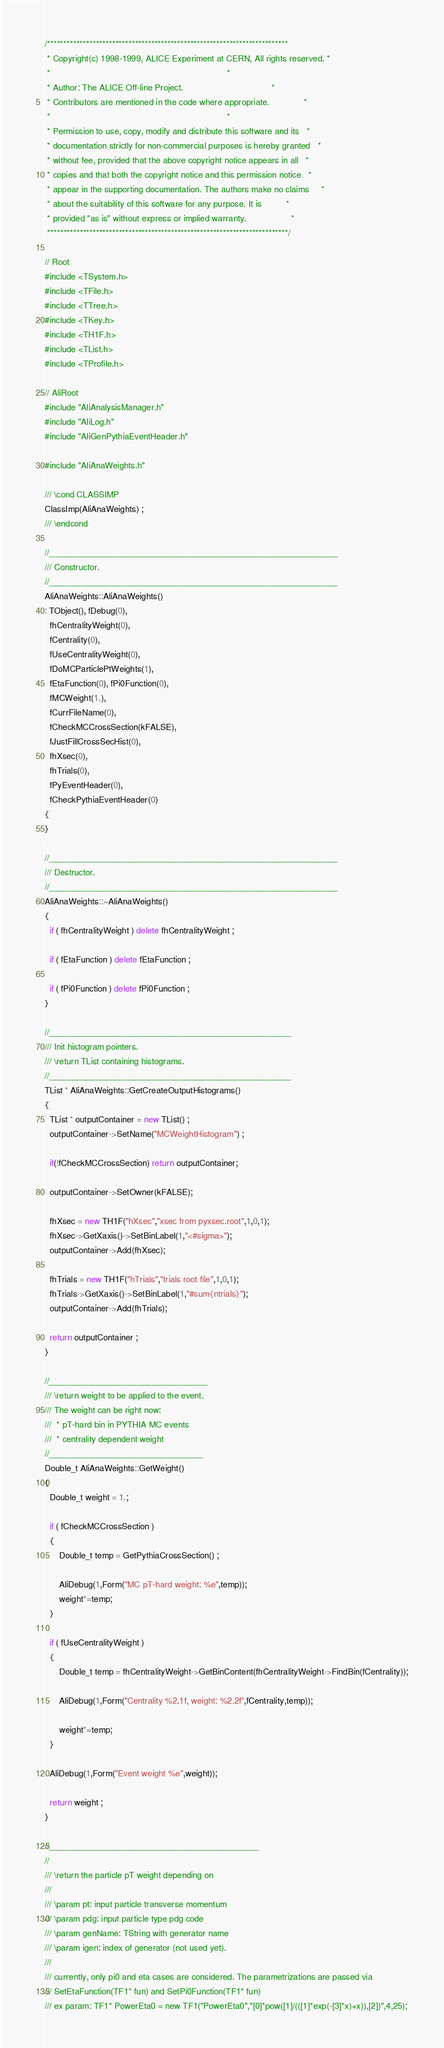Convert code to text. <code><loc_0><loc_0><loc_500><loc_500><_C++_>/**************************************************************************
 * Copyright(c) 1998-1999, ALICE Experiment at CERN, All rights reserved. *
 *                                                                        *
 * Author: The ALICE Off-line Project.                                    *
 * Contributors are mentioned in the code where appropriate.              *
 *                                                                        *
 * Permission to use, copy, modify and distribute this software and its   *
 * documentation strictly for non-commercial purposes is hereby granted   *
 * without fee, provided that the above copyright notice appears in all   *
 * copies and that both the copyright notice and this permission notice   *
 * appear in the supporting documentation. The authors make no claims     *
 * about the suitability of this software for any purpose. It is          *
 * provided "as is" without express or implied warranty.                  *
 **************************************************************************/

// Root
#include <TSystem.h>
#include <TFile.h>
#include <TTree.h>
#include <TKey.h>
#include <TH1F.h>
#include <TList.h>
#include <TProfile.h>

// AliRoot
#include "AliAnalysisManager.h"
#include "AliLog.h"
#include "AliGenPythiaEventHeader.h"

#include "AliAnaWeights.h"

/// \cond CLASSIMP
ClassImp(AliAnaWeights) ;
/// \endcond

//______________________________________________________________
/// Constructor.
//______________________________________________________________
AliAnaWeights::AliAnaWeights() 
: TObject(), fDebug(0),
  fhCentralityWeight(0),
  fCentrality(0),
  fUseCentralityWeight(0),
  fDoMCParticlePtWeights(1),
  fEtaFunction(0), fPi0Function(0), 
  fMCWeight(1.),
  fCurrFileName(0),
  fCheckMCCrossSection(kFALSE),
  fJustFillCrossSecHist(0),
  fhXsec(0),
  fhTrials(0),
  fPyEventHeader(0),
  fCheckPythiaEventHeader(0)
{
}

//______________________________________________________________
/// Destructor.
//______________________________________________________________
AliAnaWeights::~AliAnaWeights() 
{ 
  if ( fhCentralityWeight ) delete fhCentralityWeight ; 
  
  if ( fEtaFunction ) delete fEtaFunction ;
 
  if ( fPi0Function ) delete fPi0Function ;
}

//____________________________________________________
/// Init histogram pointers.
/// \return TList containing histograms.
//____________________________________________________
TList * AliAnaWeights::GetCreateOutputHistograms()
{
  TList * outputContainer = new TList() ;
  outputContainer->SetName("MCWeightHistogram") ;
    
  if(!fCheckMCCrossSection) return outputContainer;
  
  outputContainer->SetOwner(kFALSE);

  fhXsec = new TH1F("hXsec","xsec from pyxsec.root",1,0,1);
  fhXsec->GetXaxis()->SetBinLabel(1,"<#sigma>");
  outputContainer->Add(fhXsec);
    
  fhTrials = new TH1F("hTrials","trials root file",1,0,1);
  fhTrials->GetXaxis()->SetBinLabel(1,"#sum{ntrials}");
  outputContainer->Add(fhTrials);
  
  return outputContainer ;
}

//__________________________________
/// \return weight to be applied to the event.
/// The weight can be right now:
///  * pT-hard bin in PYTHIA MC events
///  * centrality dependent weight
//_________________________________
Double_t AliAnaWeights::GetWeight()
{
  Double_t weight = 1.;
      
  if ( fCheckMCCrossSection )
  {
      Double_t temp = GetPythiaCrossSection() ;
      
      AliDebug(1,Form("MC pT-hard weight: %e",temp));
      weight*=temp;
  }
    
  if ( fUseCentralityWeight )
  {
      Double_t temp = fhCentralityWeight->GetBinContent(fhCentralityWeight->FindBin(fCentrality));
      
      AliDebug(1,Form("Centrality %2.1f, weight: %2.2f",fCentrality,temp));
      
      weight*=temp;
  }
    
  AliDebug(1,Form("Event weight %e",weight));
    
  return weight ;
}

//_____________________________________________
//
/// \return the particle pT weight depending on
///
/// \param pt: input particle transverse momentum 
/// \param pdg: input particle type pdg code
/// \param genName: TString with generator name
/// \param igen: index of generator (not used yet).
///
/// currently, only pi0 and eta cases are considered. The parametrizations are passed via
/// SetEtaFunction(TF1* fun) and SetPi0Function(TF1* fun)
/// ex param: TF1* PowerEta0 = new TF1("PowerEta0","[0]*pow([1]/(([1]*exp(-[3]*x)+x)),[2])",4,25);</code> 